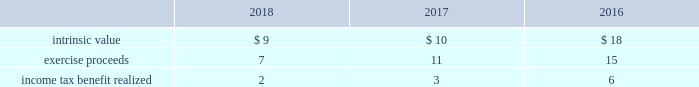The table provides the weighted average assumptions used in the black-scholes option-pricing model for grants and the resulting weighted average grant date fair value per share of stock options granted for the years ended december 31: .
Stock units during 2018 , 2017 and 2016 , the company granted rsus to certain employees under the 2007 plan and 2017 omnibus plan , as applicable .
Rsus generally vest based on continued employment with the company over periods ranging from one to three years. .
What was average income tax benefit realized for the three year period? 
Computations: table_average(income tax benefit realized, none)
Answer: 3.66667. 